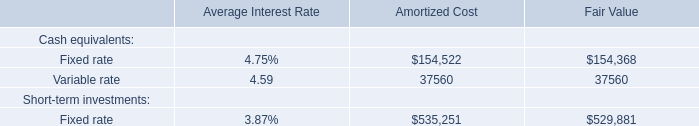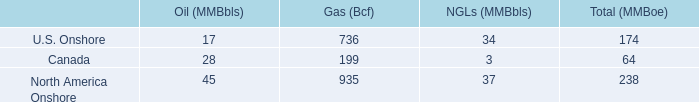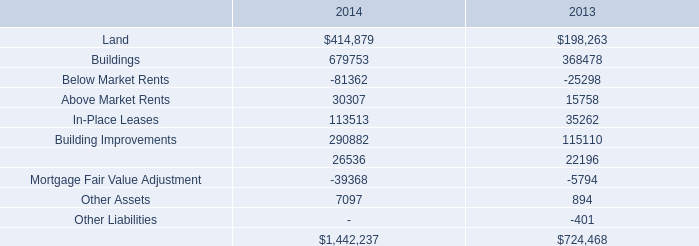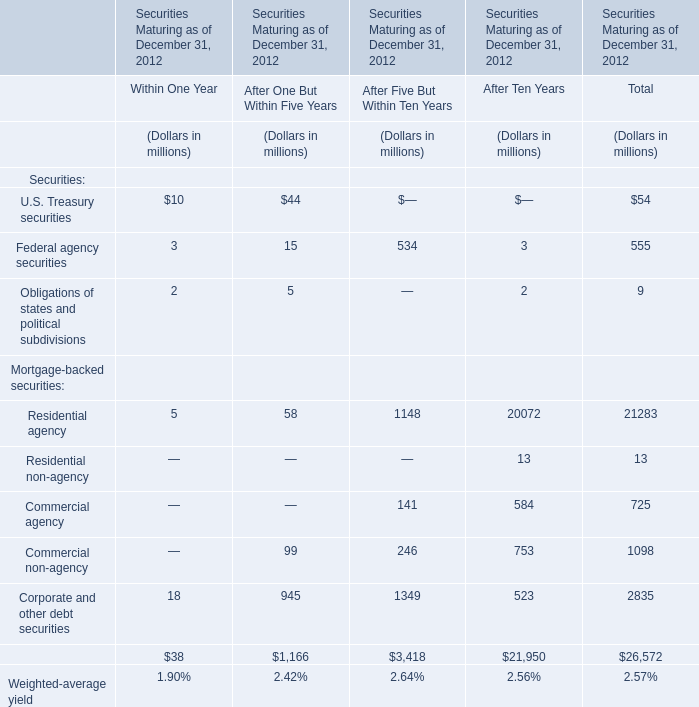What is the average amount of Mortgage Fair Value Adjustment of 2014, and Variable rate of Amortized Cost ? 
Computations: ((39368.0 + 37560.0) / 2)
Answer: 38464.0. 